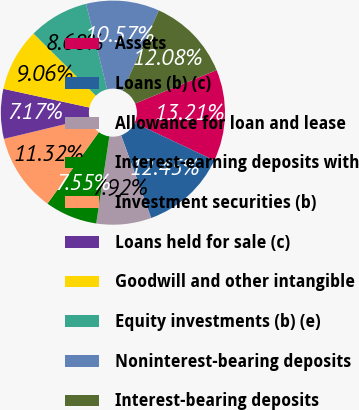Convert chart. <chart><loc_0><loc_0><loc_500><loc_500><pie_chart><fcel>Assets<fcel>Loans (b) (c)<fcel>Allowance for loan and lease<fcel>Interest-earning deposits with<fcel>Investment securities (b)<fcel>Loans held for sale (c)<fcel>Goodwill and other intangible<fcel>Equity investments (b) (e)<fcel>Noninterest-bearing deposits<fcel>Interest-bearing deposits<nl><fcel>13.21%<fcel>12.45%<fcel>7.92%<fcel>7.55%<fcel>11.32%<fcel>7.17%<fcel>9.06%<fcel>8.68%<fcel>10.57%<fcel>12.08%<nl></chart> 